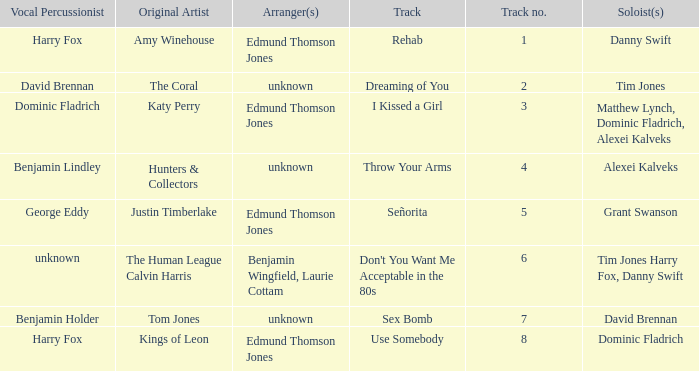Who is the arranger for "I KIssed a Girl"? Edmund Thomson Jones. 